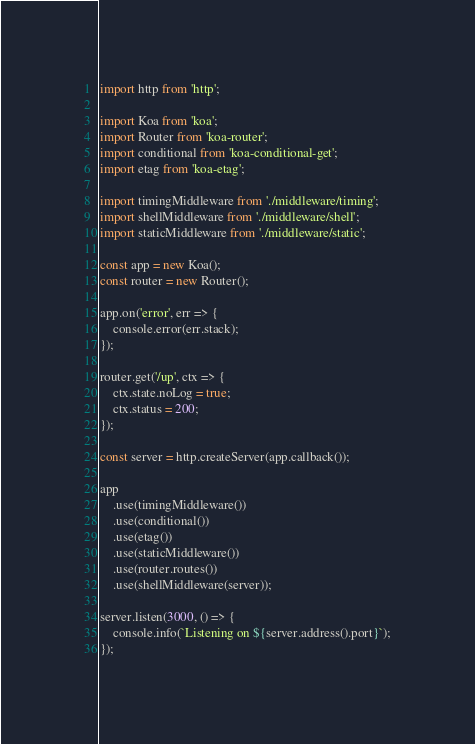<code> <loc_0><loc_0><loc_500><loc_500><_JavaScript_>import http from 'http';

import Koa from 'koa';
import Router from 'koa-router';
import conditional from 'koa-conditional-get';
import etag from 'koa-etag';

import timingMiddleware from './middleware/timing';
import shellMiddleware from './middleware/shell';
import staticMiddleware from './middleware/static';

const app = new Koa();
const router = new Router();

app.on('error', err => {
	console.error(err.stack);
});

router.get('/up', ctx => {
	ctx.state.noLog = true;
	ctx.status = 200;
});

const server = http.createServer(app.callback());

app
	.use(timingMiddleware())
	.use(conditional())
	.use(etag())
	.use(staticMiddleware())
	.use(router.routes())
	.use(shellMiddleware(server));

server.listen(3000, () => {
	console.info(`Listening on ${server.address().port}`);
});
</code> 